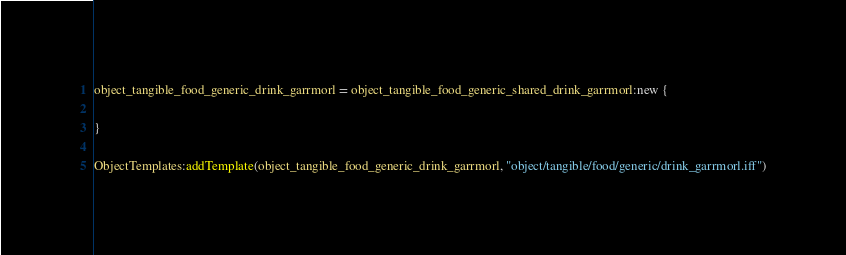<code> <loc_0><loc_0><loc_500><loc_500><_Lua_>object_tangible_food_generic_drink_garrmorl = object_tangible_food_generic_shared_drink_garrmorl:new {

}

ObjectTemplates:addTemplate(object_tangible_food_generic_drink_garrmorl, "object/tangible/food/generic/drink_garrmorl.iff")
</code> 